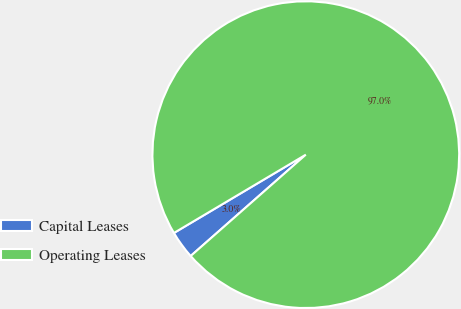Convert chart. <chart><loc_0><loc_0><loc_500><loc_500><pie_chart><fcel>Capital Leases<fcel>Operating Leases<nl><fcel>2.96%<fcel>97.04%<nl></chart> 